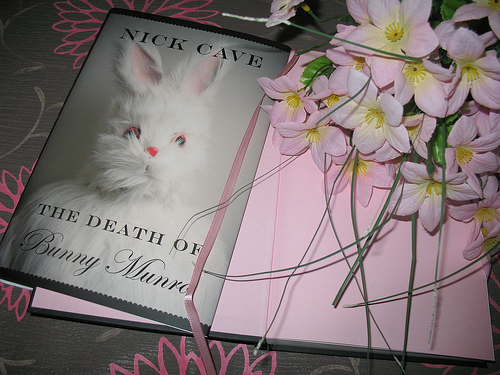<image>
Is the flowers behind the rabbit? No. The flowers is not behind the rabbit. From this viewpoint, the flowers appears to be positioned elsewhere in the scene. 